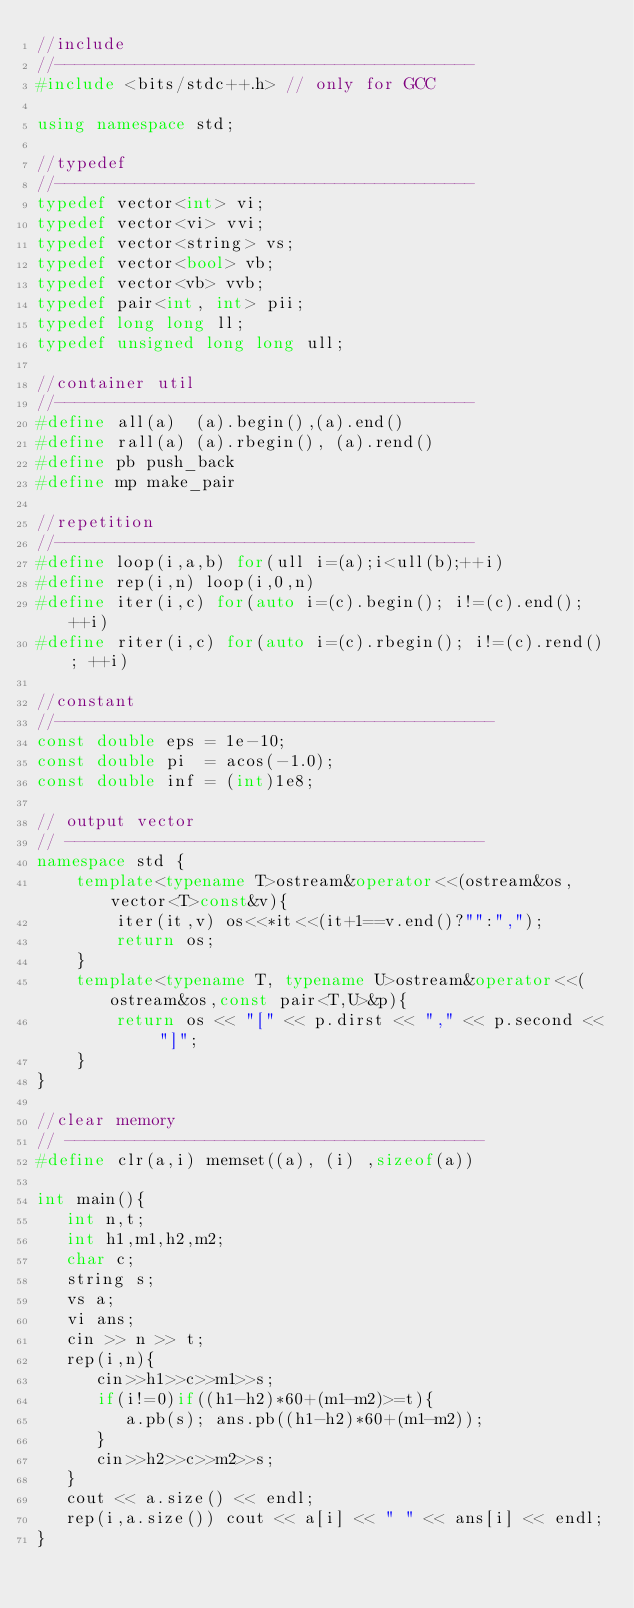Convert code to text. <code><loc_0><loc_0><loc_500><loc_500><_C++_>//include
//------------------------------------------
#include <bits/stdc++.h> // only for GCC

using namespace std;

//typedef
//------------------------------------------
typedef vector<int> vi;
typedef vector<vi> vvi;
typedef vector<string> vs;
typedef vector<bool> vb;
typedef vector<vb> vvb;
typedef pair<int, int> pii;
typedef long long ll;
typedef unsigned long long ull;

//container util
//------------------------------------------
#define all(a)  (a).begin(),(a).end()
#define rall(a) (a).rbegin(), (a).rend()
#define pb push_back
#define mp make_pair

//repetition
//------------------------------------------
#define loop(i,a,b) for(ull i=(a);i<ull(b);++i)
#define rep(i,n) loop(i,0,n)
#define iter(i,c) for(auto i=(c).begin(); i!=(c).end(); ++i)
#define riter(i,c) for(auto i=(c).rbegin(); i!=(c).rend(); ++i)

//constant
//--------------------------------------------
const double eps = 1e-10;
const double pi  = acos(-1.0);
const double inf = (int)1e8;

// output vector
// ------------------------------------------
namespace std {
    template<typename T>ostream&operator<<(ostream&os, vector<T>const&v){
        iter(it,v) os<<*it<<(it+1==v.end()?"":",");
        return os;
    }
    template<typename T, typename U>ostream&operator<<(ostream&os,const pair<T,U>&p){
        return os << "[" << p.dirst << "," << p.second << "]";
    }
}

//clear memory
// ------------------------------------------
#define clr(a,i) memset((a), (i) ,sizeof(a))

int main(){
   int n,t;
   int h1,m1,h2,m2;
   char c;
   string s;
   vs a;
   vi ans;
   cin >> n >> t;
   rep(i,n){
      cin>>h1>>c>>m1>>s;
      if(i!=0)if((h1-h2)*60+(m1-m2)>=t){
         a.pb(s); ans.pb((h1-h2)*60+(m1-m2));
      }
      cin>>h2>>c>>m2>>s;
   }
   cout << a.size() << endl;
   rep(i,a.size()) cout << a[i] << " " << ans[i] << endl;
}</code> 